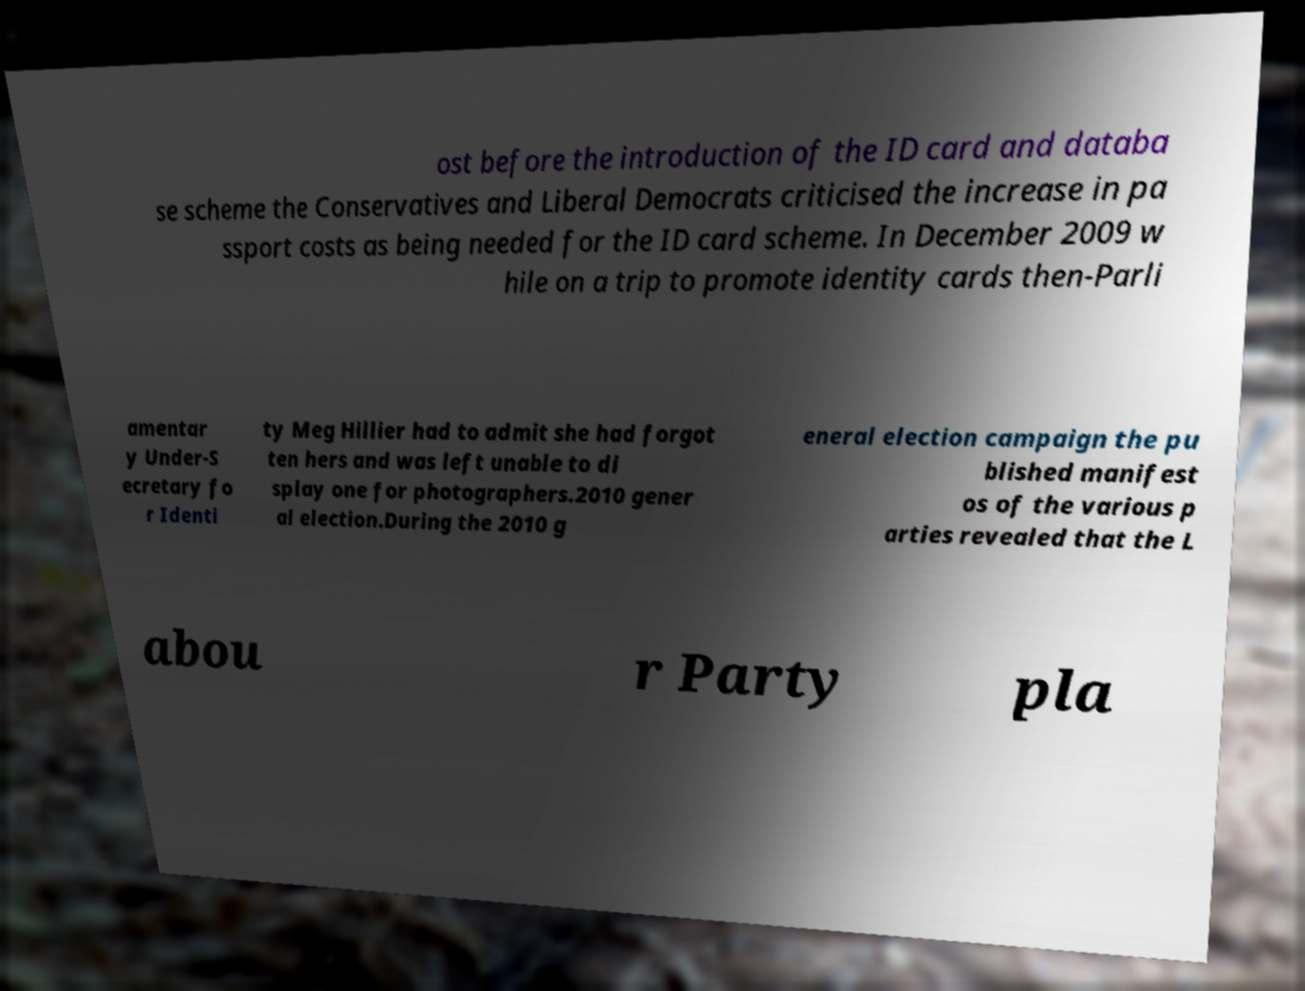Can you accurately transcribe the text from the provided image for me? ost before the introduction of the ID card and databa se scheme the Conservatives and Liberal Democrats criticised the increase in pa ssport costs as being needed for the ID card scheme. In December 2009 w hile on a trip to promote identity cards then-Parli amentar y Under-S ecretary fo r Identi ty Meg Hillier had to admit she had forgot ten hers and was left unable to di splay one for photographers.2010 gener al election.During the 2010 g eneral election campaign the pu blished manifest os of the various p arties revealed that the L abou r Party pla 